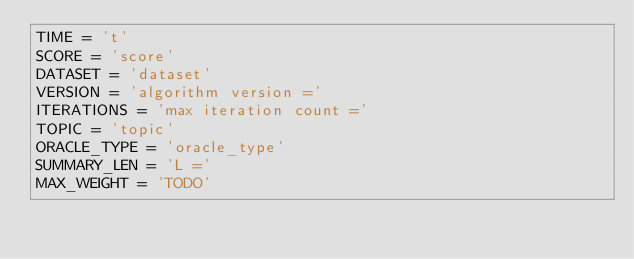Convert code to text. <code><loc_0><loc_0><loc_500><loc_500><_Python_>TIME = 't'
SCORE = 'score'
DATASET = 'dataset'
VERSION = 'algorithm version ='
ITERATIONS = 'max iteration count ='
TOPIC = 'topic'
ORACLE_TYPE = 'oracle_type'
SUMMARY_LEN = 'L ='
MAX_WEIGHT = 'TODO'
</code> 